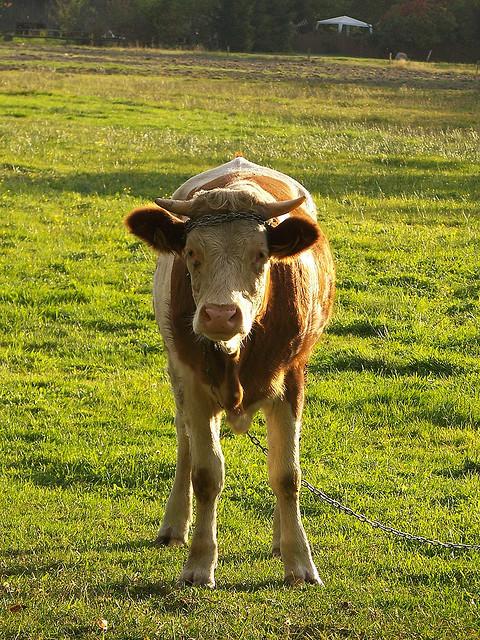Is this a cow or bull?
Be succinct. Bull. Does this animal have horns?
Concise answer only. Yes. What is the cow standing on?
Answer briefly. Grass. Is the animal looking at the camera?
Be succinct. Yes. 